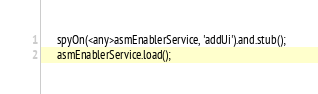<code> <loc_0><loc_0><loc_500><loc_500><_TypeScript_>      spyOn(<any>asmEnablerService, 'addUi').and.stub();
      asmEnablerService.load();</code> 